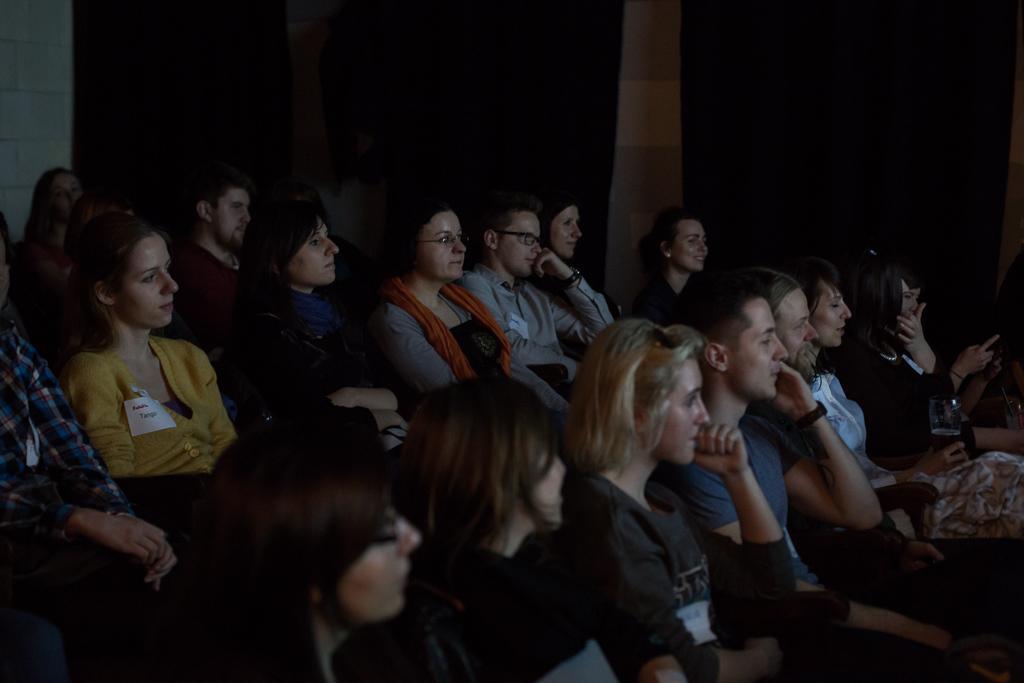In one or two sentences, can you explain what this image depicts? In this image I can see number of people sitting here. I can see few of them holding glass, phones in their hand. Few of them wearing specs and watches. In the background I can see a wall. 